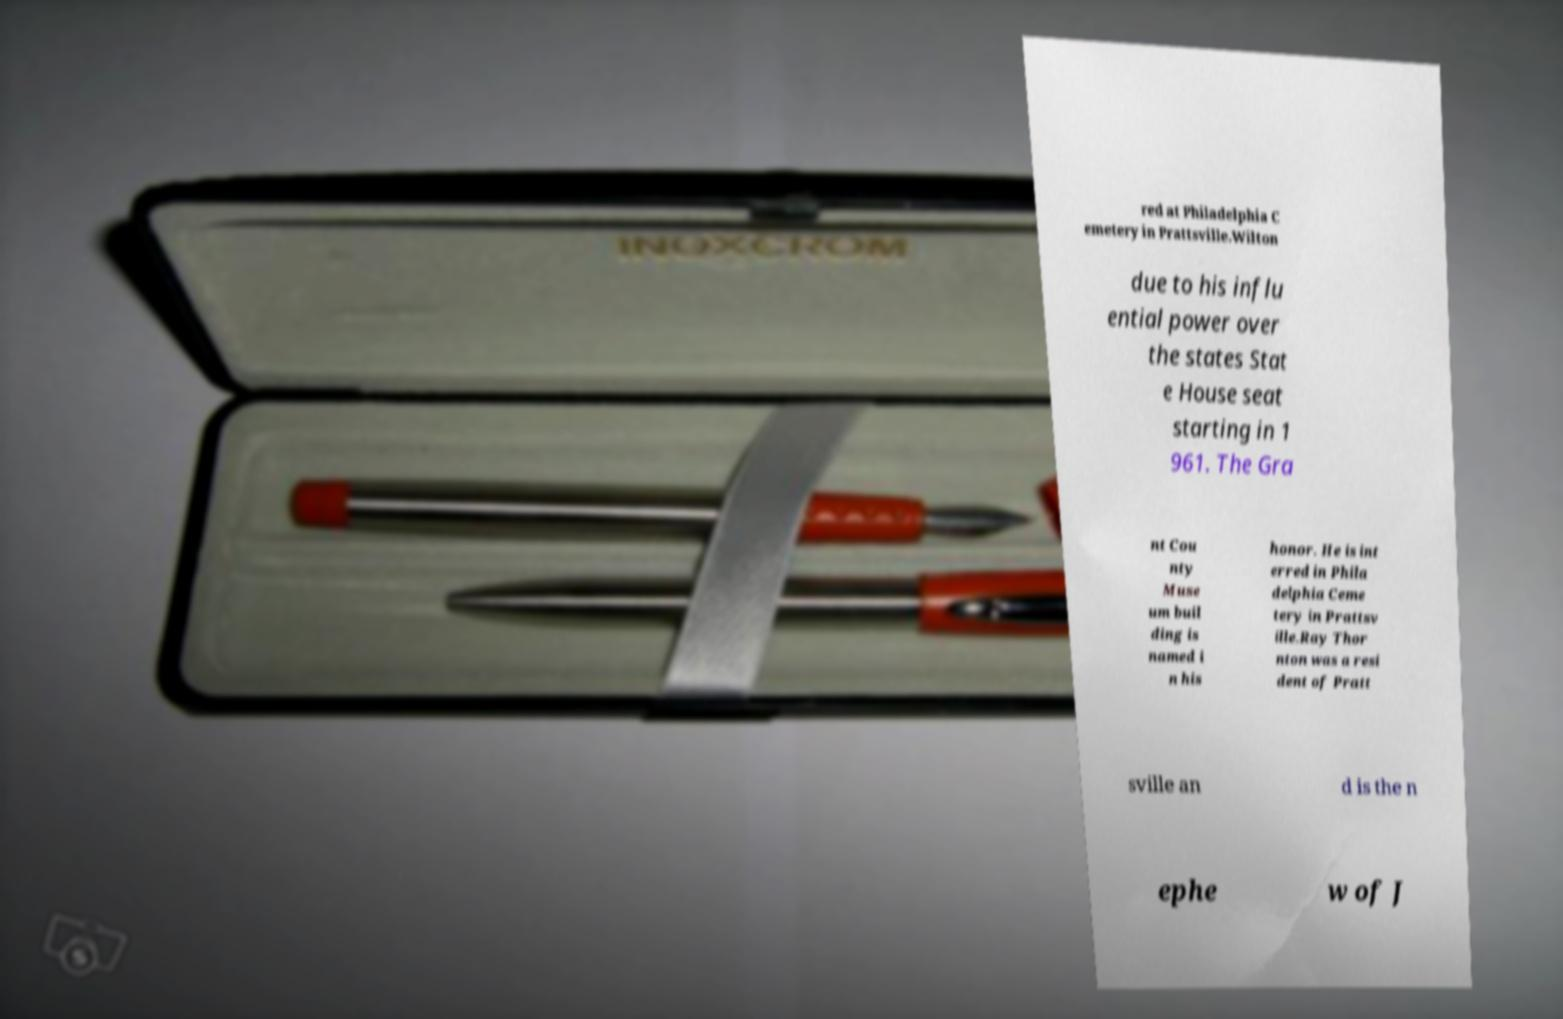What messages or text are displayed in this image? I need them in a readable, typed format. red at Philadelphia C emetery in Prattsville.Wilton due to his influ ential power over the states Stat e House seat starting in 1 961. The Gra nt Cou nty Muse um buil ding is named i n his honor. He is int erred in Phila delphia Ceme tery in Prattsv ille.Ray Thor nton was a resi dent of Pratt sville an d is the n ephe w of J 